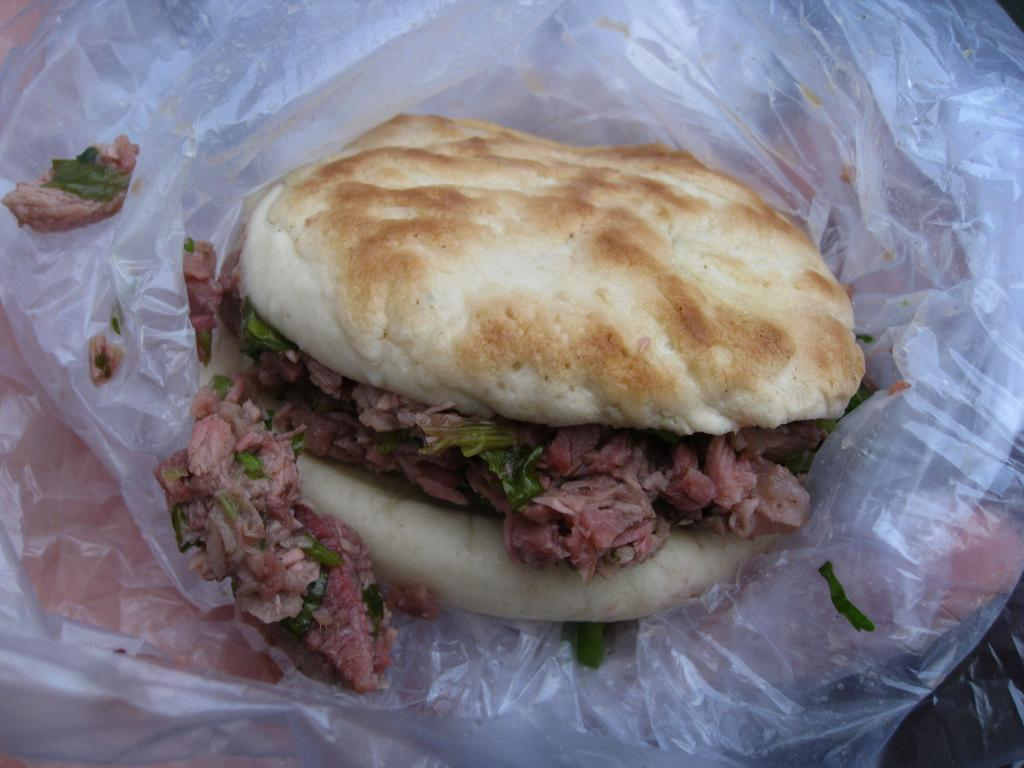What is the main subject of the image? There is a food item in the image. How is the food item being stored or protected? The food item is in a polythene cover. What type of voyage is the food item embarking on in the image? There is no indication of a voyage in the image; the food item is simply in a polythene cover. 